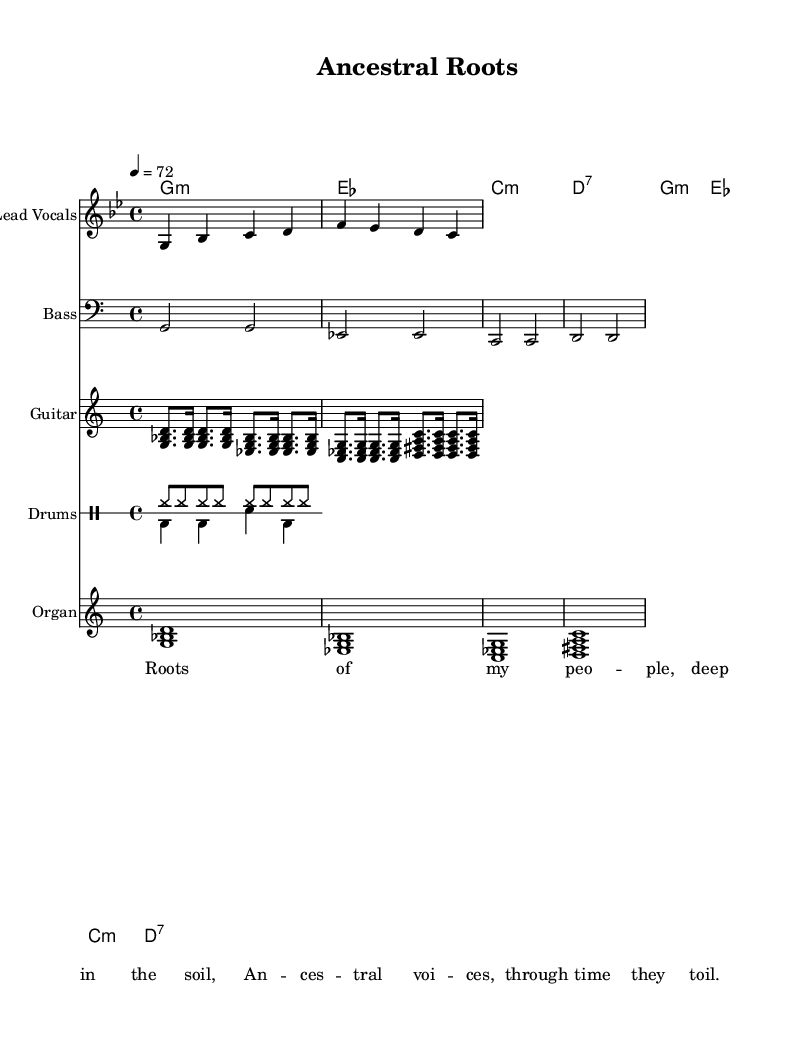What is the key signature of this music? The key signature is G minor, which has two flats (B flat and E flat). This is confirmed by the initial marking in the music indicating a G minor scale.
Answer: G minor What is the time signature? The time signature is 4/4, which indicates that there are four beats in each measure, and the quarter note gets one beat. This can be found at the beginning of the score.
Answer: 4/4 What is the tempo marking? The tempo marking indicates a speed of 72 beats per minute, as denoted by "4 = 72" at the start of the piece.
Answer: 72 What instruments are included in this arrangement? The main instruments listed in the arrangement are lead vocals, bass, guitar, drums, and organ, which can be seen as separate staves labeled in the sheet music.
Answer: Lead Vocals, Bass, Guitar, Drums, Organ How many measures are there in the melody section? The melody section consists of four measures, which can be counted directly from the melody line provided before the chord symbols. Each vertical line (bar line) indicates the end of a measure.
Answer: 4 Which specific reggae element is emphasized in this piece? The reggae element emphasized here is the guitar skank, which features distinct off-beat chords that are characteristic of reggae music. This is evident in the guitar line with the skank rhythm showing short, syncopated notes.
Answer: Guitar skank What theme do the lyrics convey? The lyrics convey themes of ancestral connections and heritage, specifically referring to the deep roots of the people in relation to the land, as stated in the line "Roots of my people, deep in the soil."
Answer: Ancestral connections 